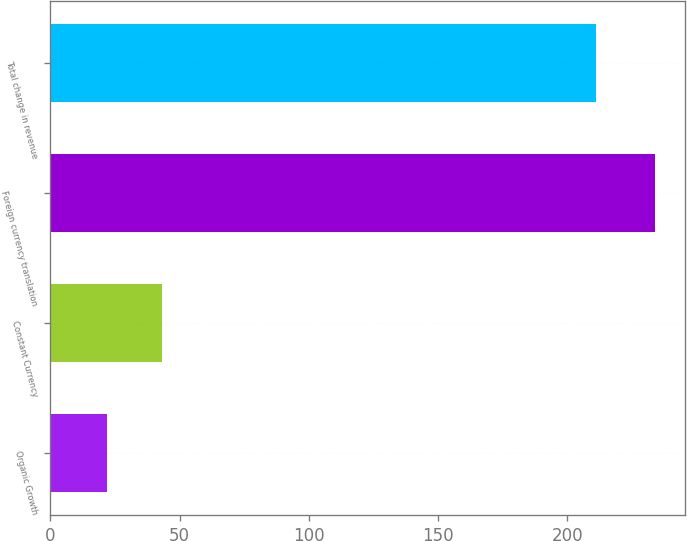<chart> <loc_0><loc_0><loc_500><loc_500><bar_chart><fcel>Organic Growth<fcel>Constant Currency<fcel>Foreign currency translation<fcel>Total change in revenue<nl><fcel>22<fcel>43.2<fcel>234<fcel>211<nl></chart> 